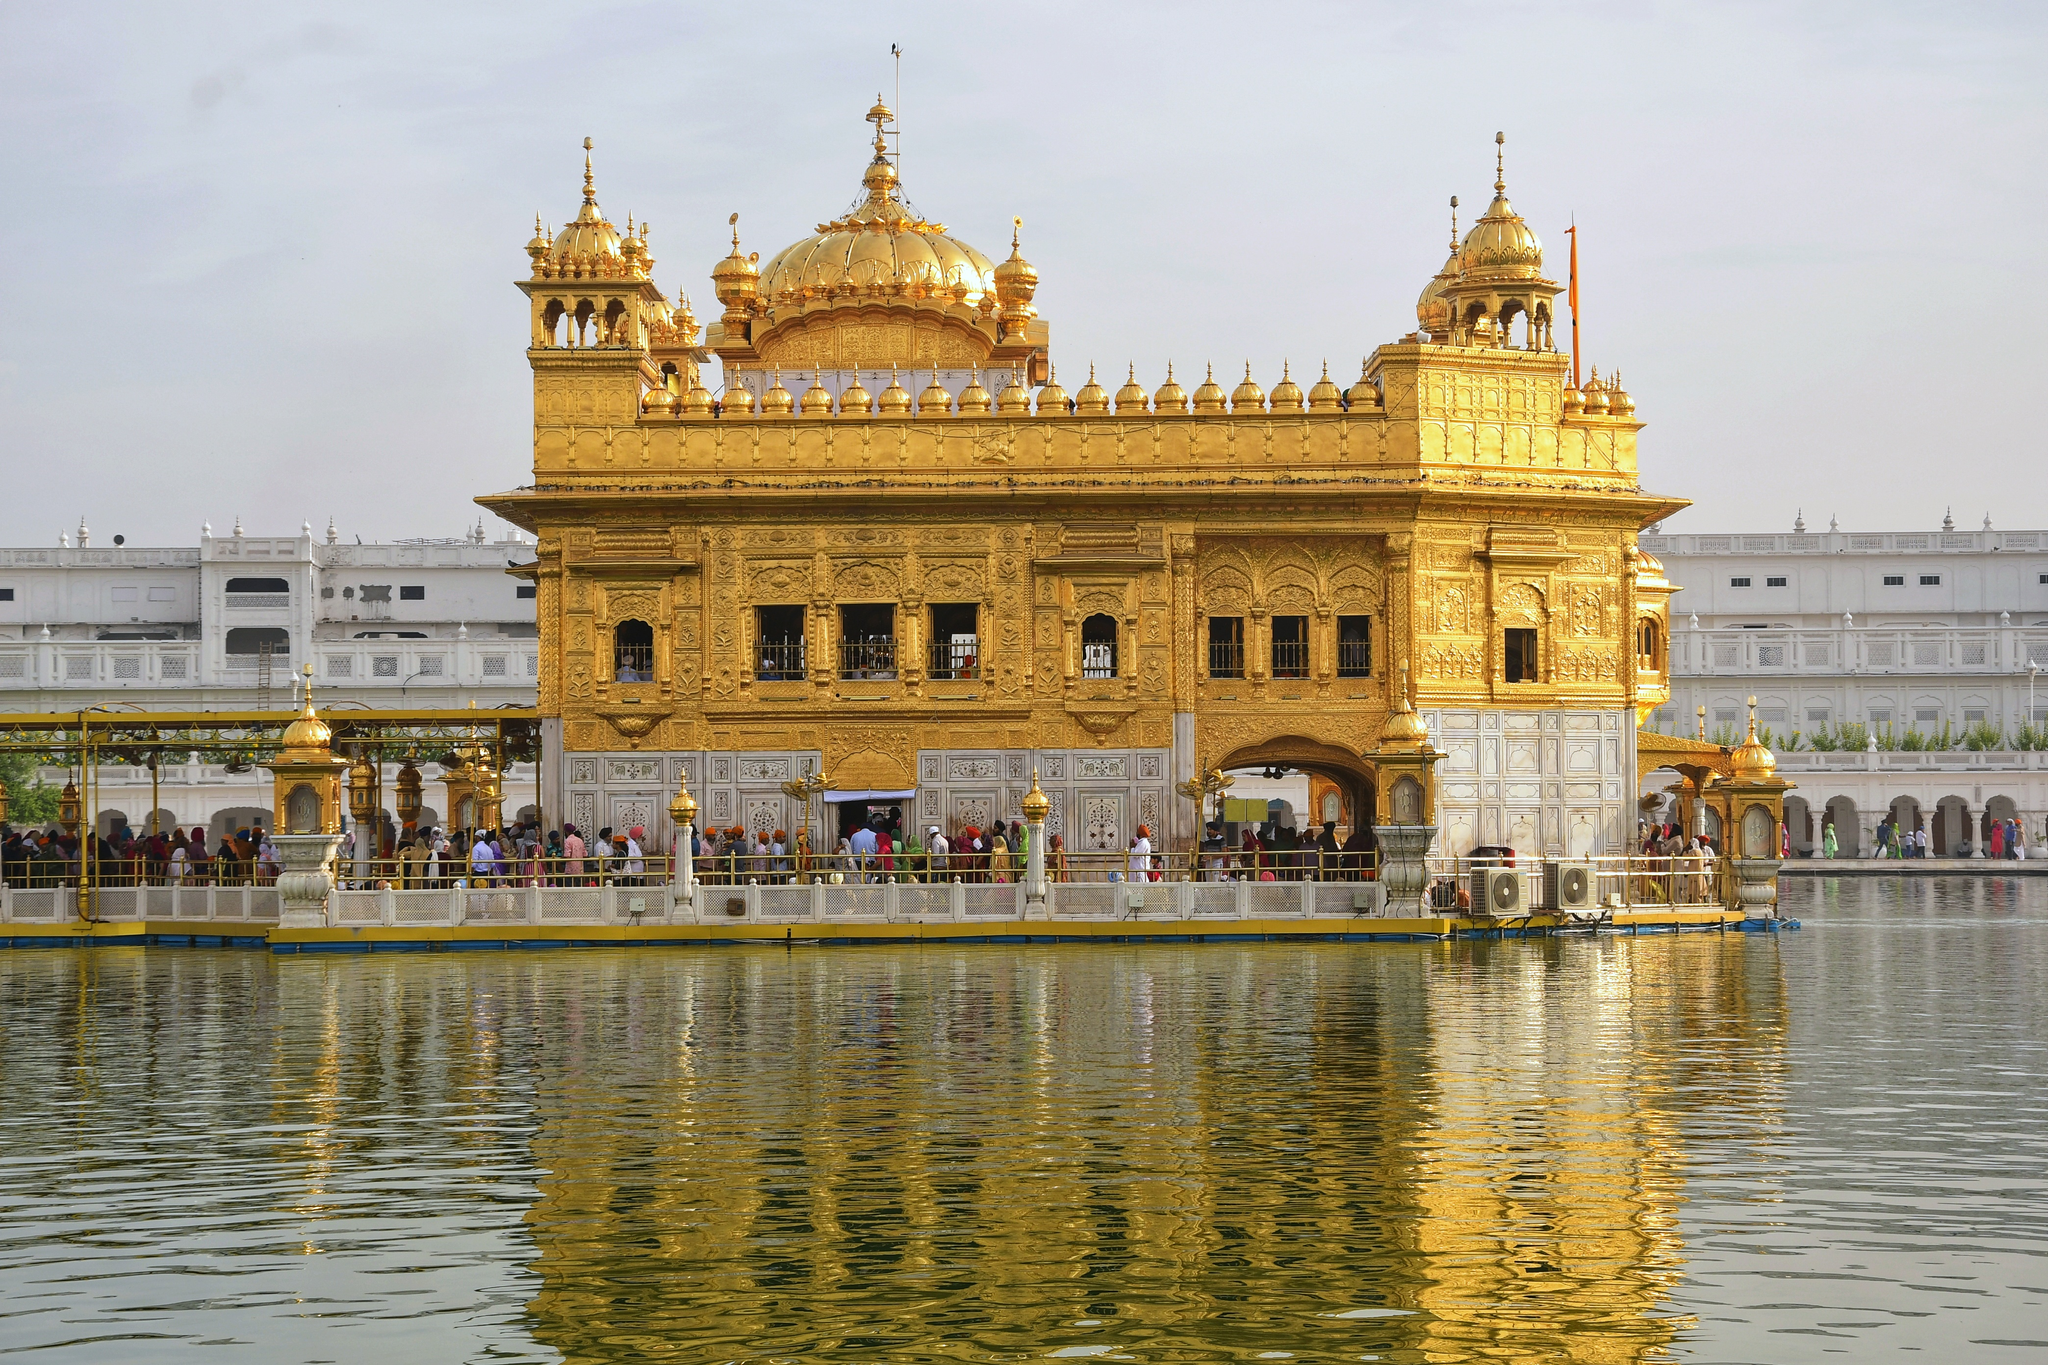What do you feel when looking at the Golden Temple reflecting in the water? The serene reflection of the Golden Temple in the water evokes a deep sense of peace and tranquility. The mirror-like reflection adds to the ethereal beauty of the temple, with the golden hues symbolizing purity and divine presence. The calm water surrounding the temple seems to invite contemplation and mindfulness, making one feel connected to something greater and more profound. Can you tell more about the significance of the water body surrounding the temple? The water body surrounding the Golden Temple is known as the 'Amrit Sarovar', translating to 'Pool of Nectar'. It holds immense religious significance for Sikhs. Pilgrims often take a dip in these holy waters, believing it has purifying powers. The sarovar represents the merging of the temporal with the serene, the material with the spiritual. It signifies purity and sanctity, providing a space for worshippers to meditate and seek solace. The reflection of the temple in the water symbolizes the unity of the physical and spiritual realms, serving as a reminder of the divine presence surrounding them. 